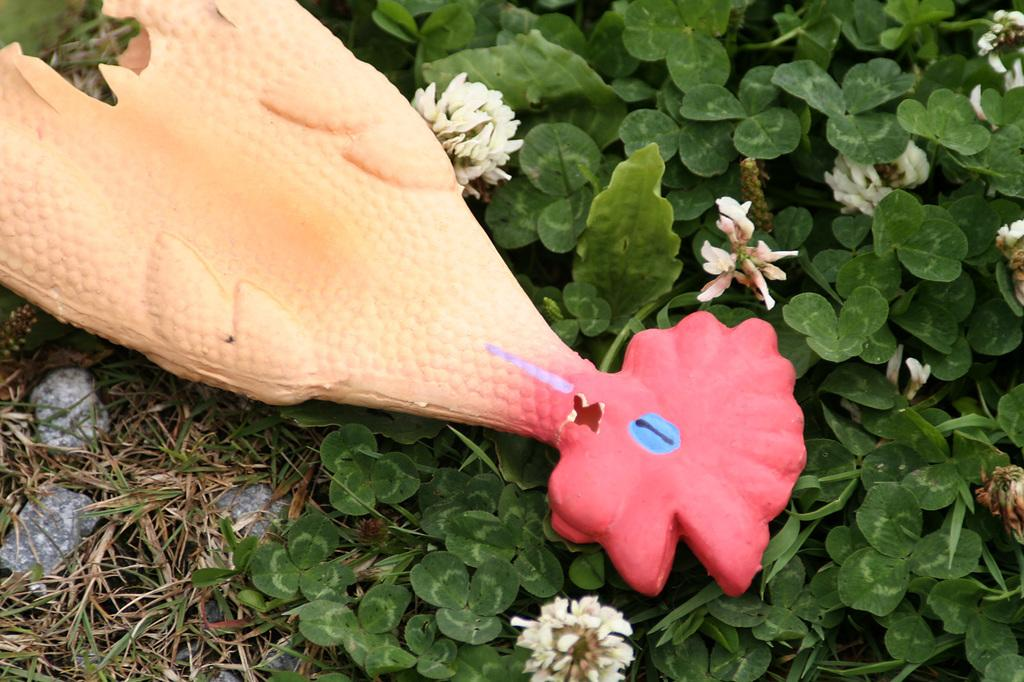What is the main subject in the center of the image? There is an object in the center of the image. What type of vegetation can be seen in the image? There are plants, flowers, and grass in the image. What other elements are present in the image? There are stones in the image. What is the title of the book that is being read in the image? There is no book or reading activity depicted in the image. 